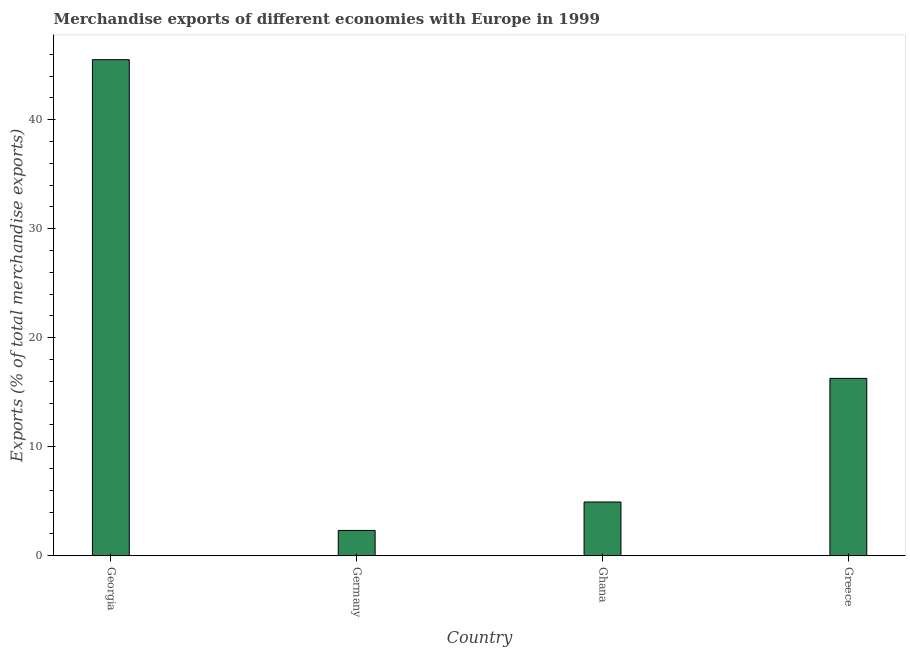What is the title of the graph?
Provide a short and direct response. Merchandise exports of different economies with Europe in 1999. What is the label or title of the X-axis?
Keep it short and to the point. Country. What is the label or title of the Y-axis?
Keep it short and to the point. Exports (% of total merchandise exports). What is the merchandise exports in Germany?
Provide a succinct answer. 2.33. Across all countries, what is the maximum merchandise exports?
Make the answer very short. 45.51. Across all countries, what is the minimum merchandise exports?
Give a very brief answer. 2.33. In which country was the merchandise exports maximum?
Provide a short and direct response. Georgia. What is the sum of the merchandise exports?
Keep it short and to the point. 69.05. What is the difference between the merchandise exports in Germany and Greece?
Your answer should be very brief. -13.95. What is the average merchandise exports per country?
Your answer should be very brief. 17.26. What is the median merchandise exports?
Keep it short and to the point. 10.61. In how many countries, is the merchandise exports greater than 2 %?
Provide a succinct answer. 4. What is the ratio of the merchandise exports in Ghana to that in Greece?
Your response must be concise. 0.3. What is the difference between the highest and the second highest merchandise exports?
Your response must be concise. 29.24. What is the difference between the highest and the lowest merchandise exports?
Offer a very short reply. 43.19. In how many countries, is the merchandise exports greater than the average merchandise exports taken over all countries?
Keep it short and to the point. 1. Are all the bars in the graph horizontal?
Make the answer very short. No. What is the difference between two consecutive major ticks on the Y-axis?
Your answer should be compact. 10. Are the values on the major ticks of Y-axis written in scientific E-notation?
Provide a short and direct response. No. What is the Exports (% of total merchandise exports) of Georgia?
Your response must be concise. 45.51. What is the Exports (% of total merchandise exports) in Germany?
Offer a very short reply. 2.33. What is the Exports (% of total merchandise exports) of Ghana?
Make the answer very short. 4.93. What is the Exports (% of total merchandise exports) in Greece?
Ensure brevity in your answer.  16.28. What is the difference between the Exports (% of total merchandise exports) in Georgia and Germany?
Your answer should be very brief. 43.19. What is the difference between the Exports (% of total merchandise exports) in Georgia and Ghana?
Your answer should be very brief. 40.58. What is the difference between the Exports (% of total merchandise exports) in Georgia and Greece?
Offer a very short reply. 29.24. What is the difference between the Exports (% of total merchandise exports) in Germany and Ghana?
Your answer should be compact. -2.61. What is the difference between the Exports (% of total merchandise exports) in Germany and Greece?
Offer a terse response. -13.95. What is the difference between the Exports (% of total merchandise exports) in Ghana and Greece?
Offer a very short reply. -11.34. What is the ratio of the Exports (% of total merchandise exports) in Georgia to that in Germany?
Provide a short and direct response. 19.56. What is the ratio of the Exports (% of total merchandise exports) in Georgia to that in Ghana?
Provide a short and direct response. 9.22. What is the ratio of the Exports (% of total merchandise exports) in Georgia to that in Greece?
Provide a short and direct response. 2.8. What is the ratio of the Exports (% of total merchandise exports) in Germany to that in Ghana?
Provide a short and direct response. 0.47. What is the ratio of the Exports (% of total merchandise exports) in Germany to that in Greece?
Provide a short and direct response. 0.14. What is the ratio of the Exports (% of total merchandise exports) in Ghana to that in Greece?
Your response must be concise. 0.3. 